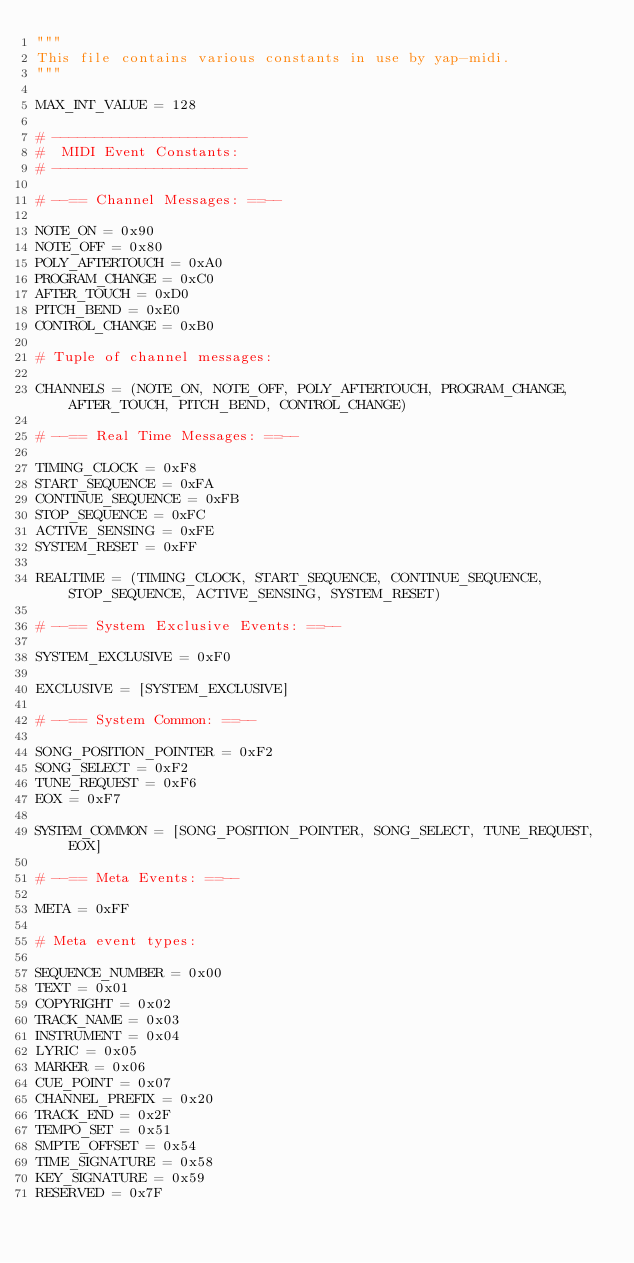Convert code to text. <code><loc_0><loc_0><loc_500><loc_500><_Python_>"""
This file contains various constants in use by yap-midi.
"""

MAX_INT_VALUE = 128

# -----------------------
#  MIDI Event Constants:
# -----------------------

# --== Channel Messages: ==--

NOTE_ON = 0x90
NOTE_OFF = 0x80
POLY_AFTERTOUCH = 0xA0
PROGRAM_CHANGE = 0xC0
AFTER_TOUCH = 0xD0
PITCH_BEND = 0xE0
CONTROL_CHANGE = 0xB0

# Tuple of channel messages:

CHANNELS = (NOTE_ON, NOTE_OFF, POLY_AFTERTOUCH, PROGRAM_CHANGE, AFTER_TOUCH, PITCH_BEND, CONTROL_CHANGE)

# --== Real Time Messages: ==--

TIMING_CLOCK = 0xF8
START_SEQUENCE = 0xFA
CONTINUE_SEQUENCE = 0xFB
STOP_SEQUENCE = 0xFC
ACTIVE_SENSING = 0xFE
SYSTEM_RESET = 0xFF

REALTIME = (TIMING_CLOCK, START_SEQUENCE, CONTINUE_SEQUENCE, STOP_SEQUENCE, ACTIVE_SENSING, SYSTEM_RESET)

# --== System Exclusive Events: ==--

SYSTEM_EXCLUSIVE = 0xF0

EXCLUSIVE = [SYSTEM_EXCLUSIVE]

# --== System Common: ==--

SONG_POSITION_POINTER = 0xF2
SONG_SELECT = 0xF2
TUNE_REQUEST = 0xF6
EOX = 0xF7

SYSTEM_COMMON = [SONG_POSITION_POINTER, SONG_SELECT, TUNE_REQUEST, EOX]

# --== Meta Events: ==--

META = 0xFF

# Meta event types:

SEQUENCE_NUMBER = 0x00
TEXT = 0x01
COPYRIGHT = 0x02
TRACK_NAME = 0x03
INSTRUMENT = 0x04
LYRIC = 0x05
MARKER = 0x06
CUE_POINT = 0x07
CHANNEL_PREFIX = 0x20
TRACK_END = 0x2F
TEMPO_SET = 0x51
SMPTE_OFFSET = 0x54
TIME_SIGNATURE = 0x58
KEY_SIGNATURE = 0x59
RESERVED = 0x7F
</code> 